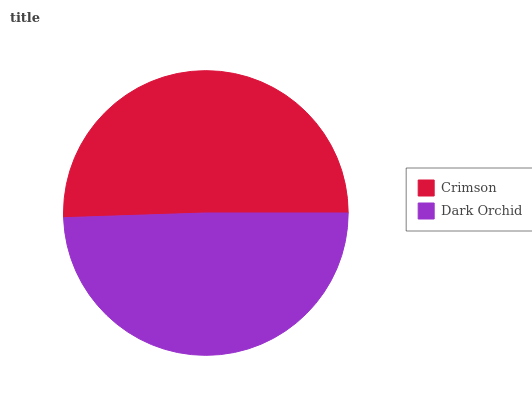Is Dark Orchid the minimum?
Answer yes or no. Yes. Is Crimson the maximum?
Answer yes or no. Yes. Is Dark Orchid the maximum?
Answer yes or no. No. Is Crimson greater than Dark Orchid?
Answer yes or no. Yes. Is Dark Orchid less than Crimson?
Answer yes or no. Yes. Is Dark Orchid greater than Crimson?
Answer yes or no. No. Is Crimson less than Dark Orchid?
Answer yes or no. No. Is Crimson the high median?
Answer yes or no. Yes. Is Dark Orchid the low median?
Answer yes or no. Yes. Is Dark Orchid the high median?
Answer yes or no. No. Is Crimson the low median?
Answer yes or no. No. 